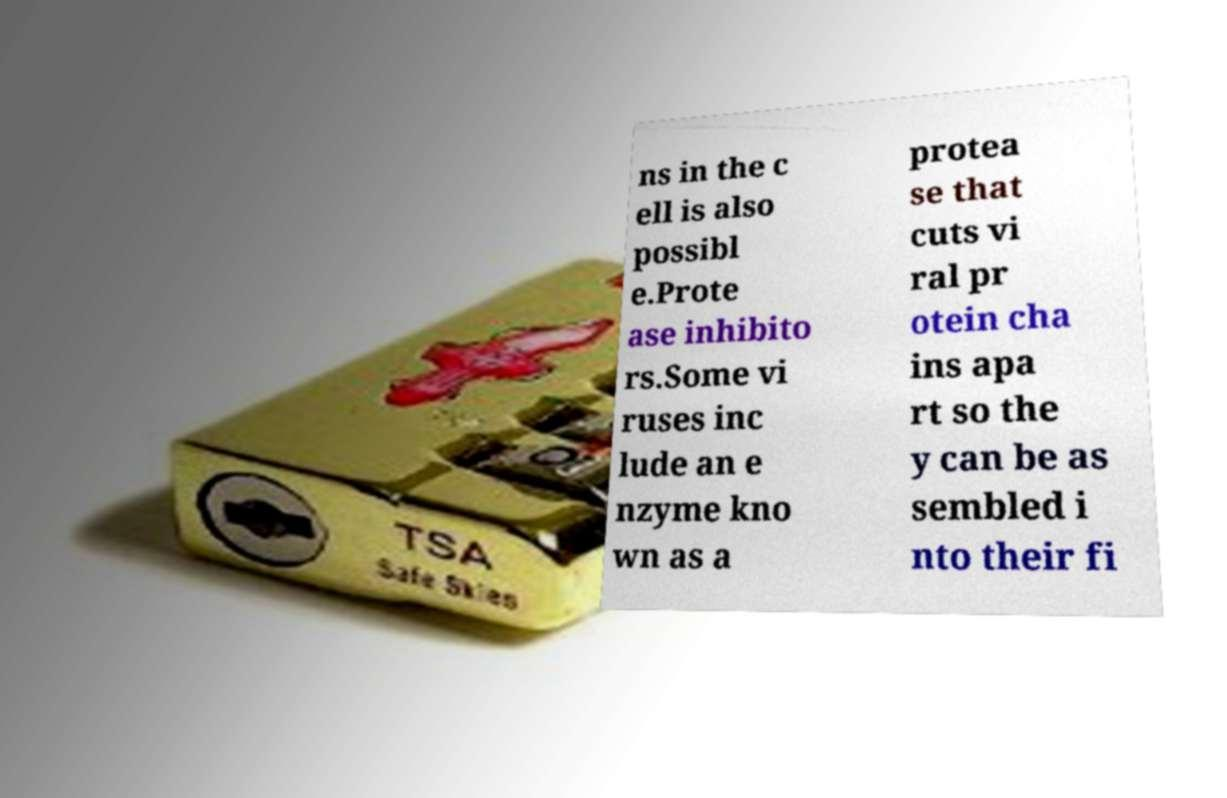Can you accurately transcribe the text from the provided image for me? ns in the c ell is also possibl e.Prote ase inhibito rs.Some vi ruses inc lude an e nzyme kno wn as a protea se that cuts vi ral pr otein cha ins apa rt so the y can be as sembled i nto their fi 